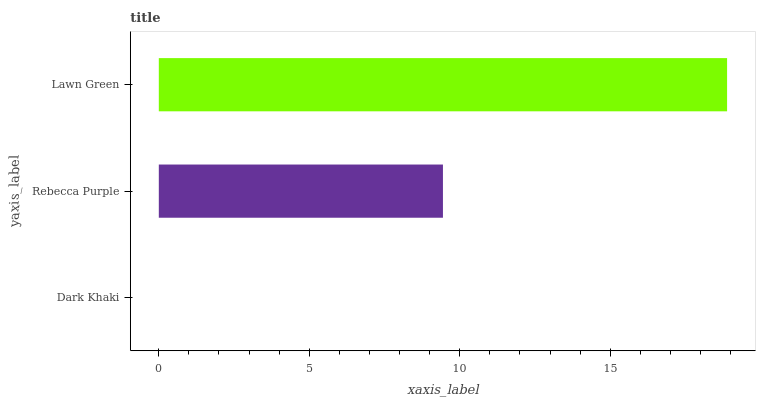Is Dark Khaki the minimum?
Answer yes or no. Yes. Is Lawn Green the maximum?
Answer yes or no. Yes. Is Rebecca Purple the minimum?
Answer yes or no. No. Is Rebecca Purple the maximum?
Answer yes or no. No. Is Rebecca Purple greater than Dark Khaki?
Answer yes or no. Yes. Is Dark Khaki less than Rebecca Purple?
Answer yes or no. Yes. Is Dark Khaki greater than Rebecca Purple?
Answer yes or no. No. Is Rebecca Purple less than Dark Khaki?
Answer yes or no. No. Is Rebecca Purple the high median?
Answer yes or no. Yes. Is Rebecca Purple the low median?
Answer yes or no. Yes. Is Dark Khaki the high median?
Answer yes or no. No. Is Dark Khaki the low median?
Answer yes or no. No. 